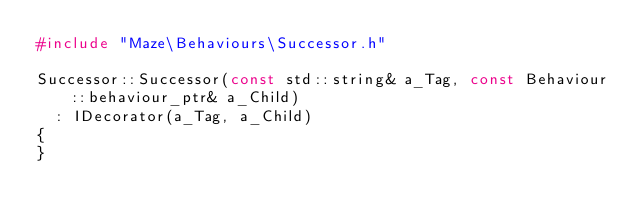<code> <loc_0><loc_0><loc_500><loc_500><_C++_>#include "Maze\Behaviours\Successor.h"

Successor::Successor(const std::string& a_Tag, const Behaviour::behaviour_ptr& a_Child)
	: IDecorator(a_Tag, a_Child)
{
}
</code> 